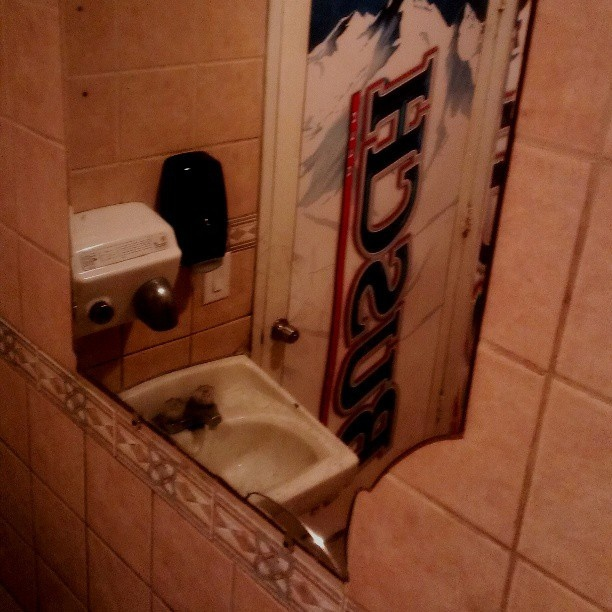Describe the objects in this image and their specific colors. I can see a sink in maroon, gray, and brown tones in this image. 